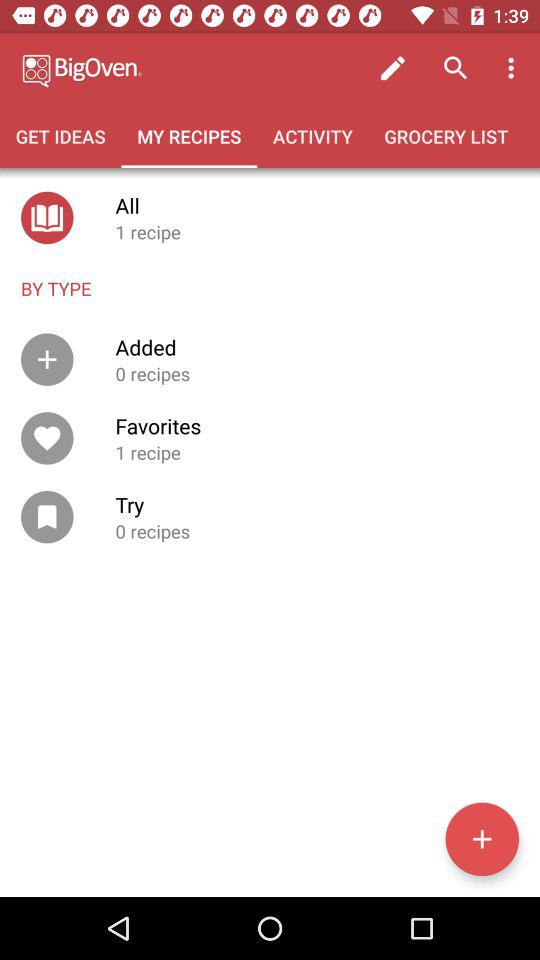How many more recipes are in my favorites than in my added recipes? Based on the image of your recipe manager, you have the same number of recipes in your 'Favorites' as in your 'Added' category, which is one recipe each. Therefore, there are no additional recipes in your 'Favorites' compared to your 'Added' recipes. 